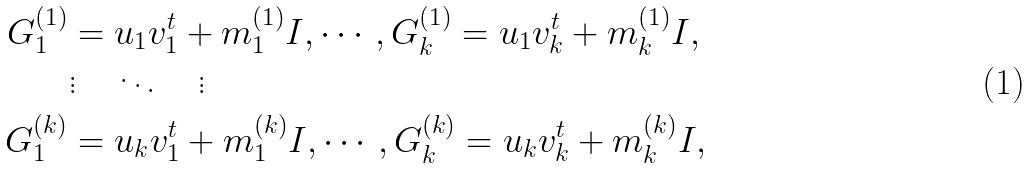<formula> <loc_0><loc_0><loc_500><loc_500>G _ { 1 } ^ { ( 1 ) } & = u _ { 1 } v _ { 1 } ^ { t } + m _ { 1 } ^ { ( 1 ) } I , \cdots , G _ { k } ^ { ( 1 ) } = u _ { 1 } v _ { k } ^ { t } + m _ { k } ^ { ( 1 ) } I , \\ & \vdots \quad \ddots \quad \vdots \\ G _ { 1 } ^ { ( k ) } & = u _ { k } v _ { 1 } ^ { t } + m _ { 1 } ^ { ( k ) } I , \cdots , G _ { k } ^ { ( k ) } = u _ { k } v _ { k } ^ { t } + m _ { k } ^ { ( k ) } I , \\</formula> 